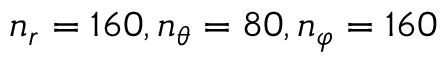<formula> <loc_0><loc_0><loc_500><loc_500>n _ { r } = 1 6 0 , n _ { \theta } = 8 0 , n _ { \varphi } = 1 6 0</formula> 